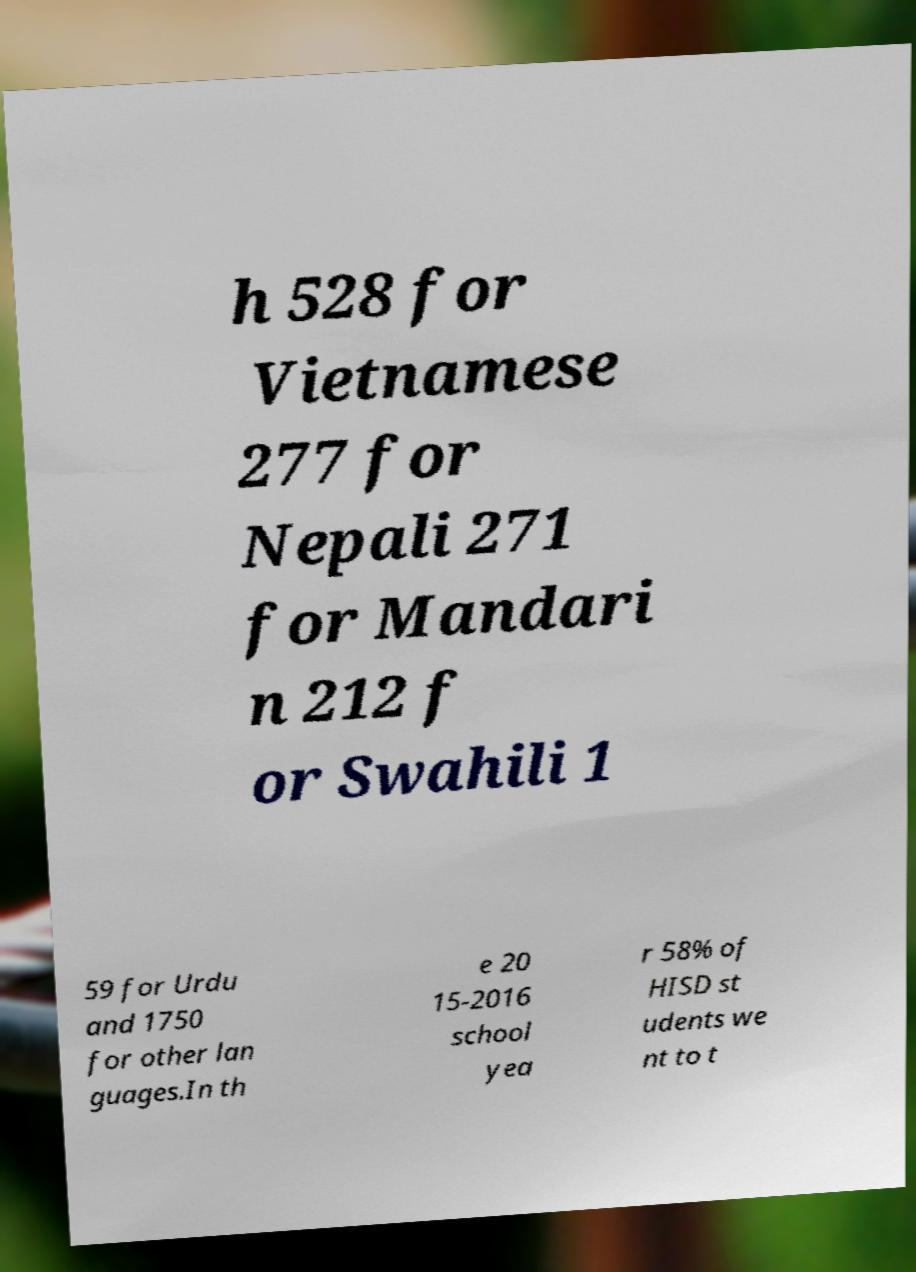Can you accurately transcribe the text from the provided image for me? h 528 for Vietnamese 277 for Nepali 271 for Mandari n 212 f or Swahili 1 59 for Urdu and 1750 for other lan guages.In th e 20 15-2016 school yea r 58% of HISD st udents we nt to t 